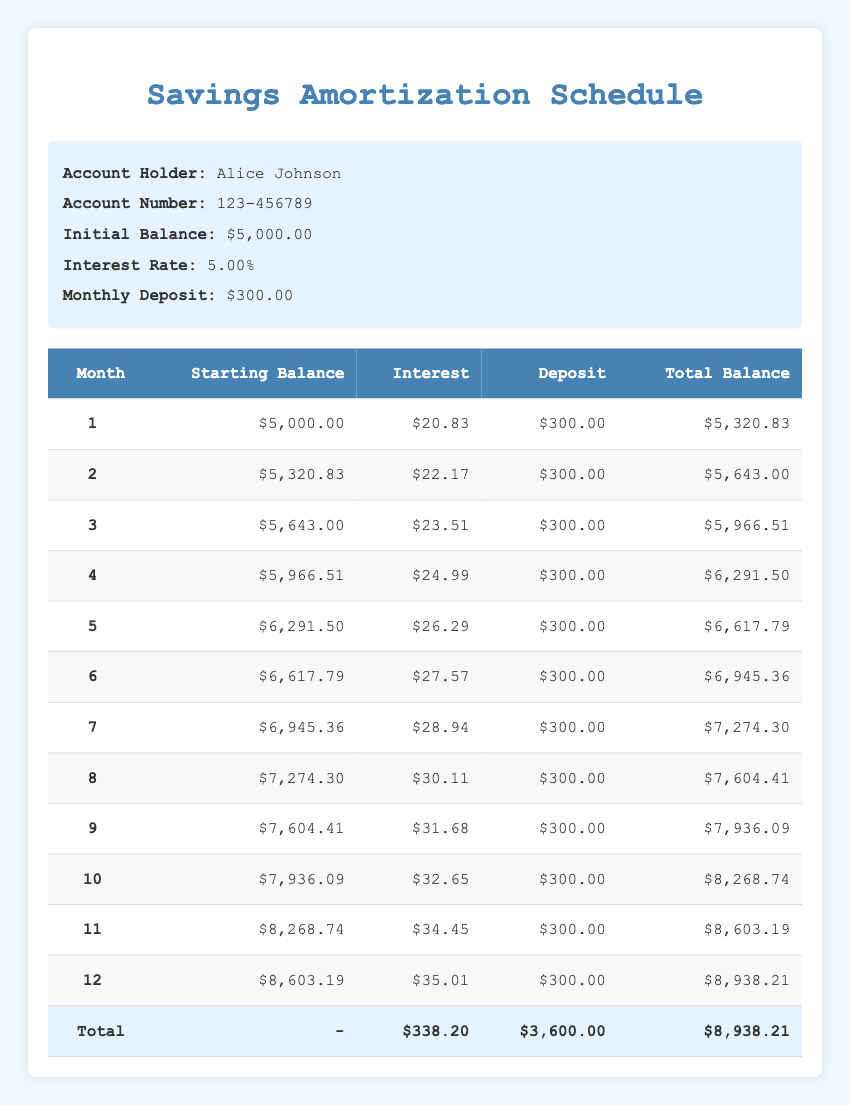What is the total balance at the end of the 12th month? The total balance at the end of the 12th month is located in the last row of the table under the "Total Balance" column, which is $8,938.21.
Answer: $8,938.21 What was the interest earned in the 6th month? To find the interest earned in the 6th month, we look at the row for month 6 in the "Interest" column, which shows $27.57.
Answer: $27.57 What is the average monthly deposit over the entire period? The monthly deposit is consistent at $300 for 12 months, so the total deposits are calculated as $300 multiplied by 12, which equals $3,600. The average is the same as the monthly deposit, which is $300.
Answer: $300 How much total interest was earned over the 12 months? To find the total interest earned, we sum all the values in the "Interest" column, which amounts to $338.20 over the 12 months.
Answer: $338.20 Is the total balance after one month greater than $5,500? The total balance after one month can be found in the first month row under the "Total Balance" column, which is $5,320.83. Since $5,320.83 is less than $5,500, the answer is no.
Answer: No What is the difference in total balance from the end of the 3rd month to the end of the 6th month? The total balance at the end of the 3rd month is $5,966.51 and at the end of the 6th month is $6,945.36. The difference is calculated as $6,945.36 minus $5,966.51, which equals $978.85.
Answer: $978.85 What is the starting balance during month 10? The starting balance in month 10 can be found in the row for month 10 under the "Starting Balance" column, which indicates $7,936.09.
Answer: $7,936.09 How much interest did Alice earn from month 7 to month 12 combined? To find the combined interest from month 7 to month 12, we sum the interest values from those months: $28.94 + $30.11 + $31.68 + $32.65 + $34.45 + $35.01, resulting in a total of $192.84.
Answer: $192.84 